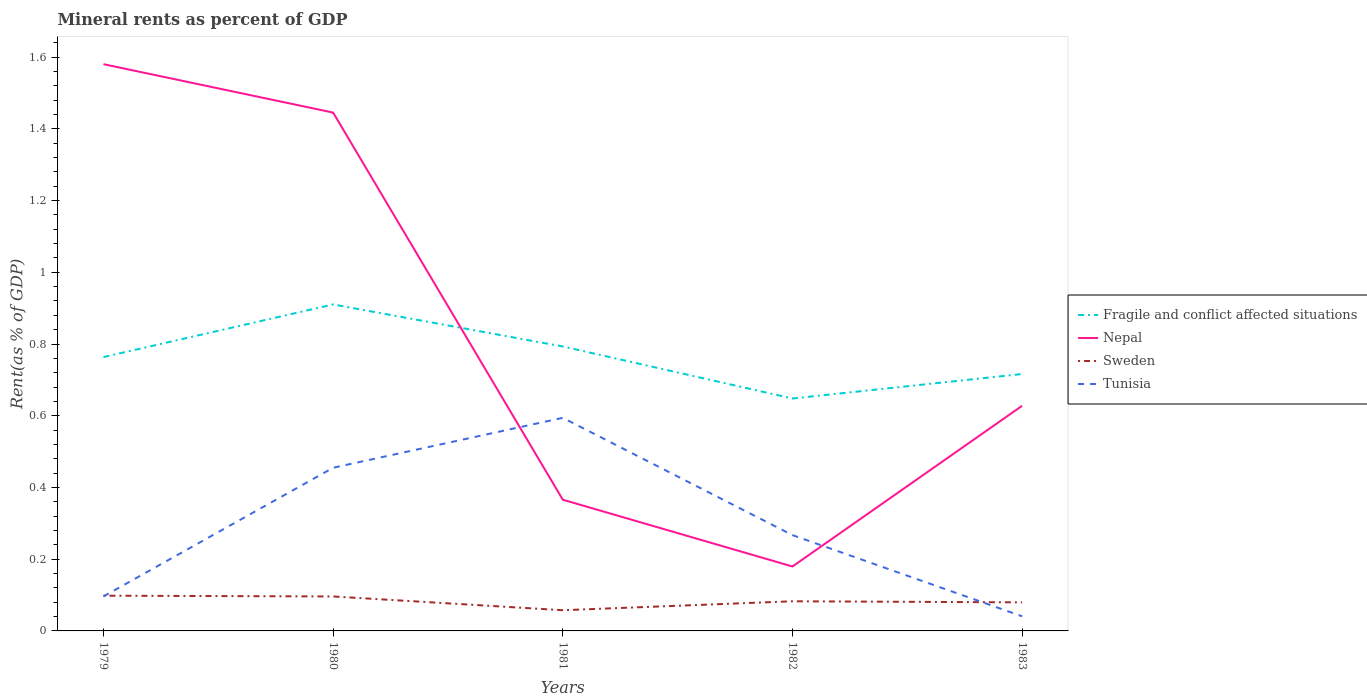How many different coloured lines are there?
Offer a terse response. 4. Is the number of lines equal to the number of legend labels?
Ensure brevity in your answer.  Yes. Across all years, what is the maximum mineral rent in Fragile and conflict affected situations?
Keep it short and to the point. 0.65. What is the total mineral rent in Fragile and conflict affected situations in the graph?
Keep it short and to the point. -0.15. What is the difference between the highest and the second highest mineral rent in Nepal?
Your answer should be compact. 1.4. What is the difference between the highest and the lowest mineral rent in Tunisia?
Provide a short and direct response. 2. How many lines are there?
Offer a terse response. 4. How many years are there in the graph?
Make the answer very short. 5. What is the difference between two consecutive major ticks on the Y-axis?
Your response must be concise. 0.2. Does the graph contain any zero values?
Offer a terse response. No. How many legend labels are there?
Your answer should be very brief. 4. How are the legend labels stacked?
Keep it short and to the point. Vertical. What is the title of the graph?
Your answer should be compact. Mineral rents as percent of GDP. Does "Palau" appear as one of the legend labels in the graph?
Your answer should be very brief. No. What is the label or title of the X-axis?
Offer a terse response. Years. What is the label or title of the Y-axis?
Give a very brief answer. Rent(as % of GDP). What is the Rent(as % of GDP) of Fragile and conflict affected situations in 1979?
Your answer should be very brief. 0.76. What is the Rent(as % of GDP) of Nepal in 1979?
Your answer should be compact. 1.58. What is the Rent(as % of GDP) of Sweden in 1979?
Offer a terse response. 0.1. What is the Rent(as % of GDP) in Tunisia in 1979?
Provide a short and direct response. 0.1. What is the Rent(as % of GDP) of Fragile and conflict affected situations in 1980?
Offer a very short reply. 0.91. What is the Rent(as % of GDP) in Nepal in 1980?
Provide a short and direct response. 1.45. What is the Rent(as % of GDP) of Sweden in 1980?
Your answer should be very brief. 0.1. What is the Rent(as % of GDP) in Tunisia in 1980?
Offer a terse response. 0.46. What is the Rent(as % of GDP) of Fragile and conflict affected situations in 1981?
Offer a terse response. 0.79. What is the Rent(as % of GDP) of Nepal in 1981?
Your response must be concise. 0.37. What is the Rent(as % of GDP) of Sweden in 1981?
Make the answer very short. 0.06. What is the Rent(as % of GDP) in Tunisia in 1981?
Keep it short and to the point. 0.59. What is the Rent(as % of GDP) in Fragile and conflict affected situations in 1982?
Provide a succinct answer. 0.65. What is the Rent(as % of GDP) in Nepal in 1982?
Make the answer very short. 0.18. What is the Rent(as % of GDP) of Sweden in 1982?
Provide a succinct answer. 0.08. What is the Rent(as % of GDP) in Tunisia in 1982?
Your response must be concise. 0.27. What is the Rent(as % of GDP) of Fragile and conflict affected situations in 1983?
Provide a succinct answer. 0.72. What is the Rent(as % of GDP) of Nepal in 1983?
Make the answer very short. 0.63. What is the Rent(as % of GDP) in Sweden in 1983?
Give a very brief answer. 0.08. What is the Rent(as % of GDP) of Tunisia in 1983?
Make the answer very short. 0.04. Across all years, what is the maximum Rent(as % of GDP) of Fragile and conflict affected situations?
Provide a succinct answer. 0.91. Across all years, what is the maximum Rent(as % of GDP) in Nepal?
Your answer should be very brief. 1.58. Across all years, what is the maximum Rent(as % of GDP) of Sweden?
Keep it short and to the point. 0.1. Across all years, what is the maximum Rent(as % of GDP) in Tunisia?
Offer a very short reply. 0.59. Across all years, what is the minimum Rent(as % of GDP) in Fragile and conflict affected situations?
Ensure brevity in your answer.  0.65. Across all years, what is the minimum Rent(as % of GDP) of Nepal?
Give a very brief answer. 0.18. Across all years, what is the minimum Rent(as % of GDP) in Sweden?
Your answer should be very brief. 0.06. Across all years, what is the minimum Rent(as % of GDP) in Tunisia?
Your answer should be very brief. 0.04. What is the total Rent(as % of GDP) in Fragile and conflict affected situations in the graph?
Provide a short and direct response. 3.83. What is the total Rent(as % of GDP) of Nepal in the graph?
Your answer should be very brief. 4.2. What is the total Rent(as % of GDP) of Sweden in the graph?
Provide a short and direct response. 0.41. What is the total Rent(as % of GDP) in Tunisia in the graph?
Keep it short and to the point. 1.45. What is the difference between the Rent(as % of GDP) of Fragile and conflict affected situations in 1979 and that in 1980?
Provide a succinct answer. -0.15. What is the difference between the Rent(as % of GDP) in Nepal in 1979 and that in 1980?
Provide a succinct answer. 0.14. What is the difference between the Rent(as % of GDP) of Sweden in 1979 and that in 1980?
Provide a succinct answer. 0. What is the difference between the Rent(as % of GDP) in Tunisia in 1979 and that in 1980?
Offer a terse response. -0.36. What is the difference between the Rent(as % of GDP) in Fragile and conflict affected situations in 1979 and that in 1981?
Make the answer very short. -0.03. What is the difference between the Rent(as % of GDP) in Nepal in 1979 and that in 1981?
Provide a short and direct response. 1.21. What is the difference between the Rent(as % of GDP) of Sweden in 1979 and that in 1981?
Your answer should be very brief. 0.04. What is the difference between the Rent(as % of GDP) of Tunisia in 1979 and that in 1981?
Give a very brief answer. -0.5. What is the difference between the Rent(as % of GDP) of Fragile and conflict affected situations in 1979 and that in 1982?
Offer a terse response. 0.12. What is the difference between the Rent(as % of GDP) in Nepal in 1979 and that in 1982?
Make the answer very short. 1.4. What is the difference between the Rent(as % of GDP) in Sweden in 1979 and that in 1982?
Provide a succinct answer. 0.02. What is the difference between the Rent(as % of GDP) of Tunisia in 1979 and that in 1982?
Provide a succinct answer. -0.17. What is the difference between the Rent(as % of GDP) in Fragile and conflict affected situations in 1979 and that in 1983?
Provide a short and direct response. 0.05. What is the difference between the Rent(as % of GDP) in Nepal in 1979 and that in 1983?
Provide a succinct answer. 0.95. What is the difference between the Rent(as % of GDP) of Sweden in 1979 and that in 1983?
Ensure brevity in your answer.  0.02. What is the difference between the Rent(as % of GDP) in Tunisia in 1979 and that in 1983?
Provide a succinct answer. 0.06. What is the difference between the Rent(as % of GDP) in Fragile and conflict affected situations in 1980 and that in 1981?
Your answer should be compact. 0.12. What is the difference between the Rent(as % of GDP) in Nepal in 1980 and that in 1981?
Keep it short and to the point. 1.08. What is the difference between the Rent(as % of GDP) in Sweden in 1980 and that in 1981?
Keep it short and to the point. 0.04. What is the difference between the Rent(as % of GDP) in Tunisia in 1980 and that in 1981?
Your answer should be compact. -0.14. What is the difference between the Rent(as % of GDP) in Fragile and conflict affected situations in 1980 and that in 1982?
Make the answer very short. 0.26. What is the difference between the Rent(as % of GDP) in Nepal in 1980 and that in 1982?
Your response must be concise. 1.27. What is the difference between the Rent(as % of GDP) of Sweden in 1980 and that in 1982?
Keep it short and to the point. 0.01. What is the difference between the Rent(as % of GDP) in Tunisia in 1980 and that in 1982?
Your answer should be compact. 0.19. What is the difference between the Rent(as % of GDP) of Fragile and conflict affected situations in 1980 and that in 1983?
Ensure brevity in your answer.  0.19. What is the difference between the Rent(as % of GDP) in Nepal in 1980 and that in 1983?
Provide a succinct answer. 0.82. What is the difference between the Rent(as % of GDP) in Sweden in 1980 and that in 1983?
Offer a terse response. 0.02. What is the difference between the Rent(as % of GDP) in Tunisia in 1980 and that in 1983?
Keep it short and to the point. 0.41. What is the difference between the Rent(as % of GDP) of Fragile and conflict affected situations in 1981 and that in 1982?
Keep it short and to the point. 0.15. What is the difference between the Rent(as % of GDP) in Nepal in 1981 and that in 1982?
Offer a terse response. 0.19. What is the difference between the Rent(as % of GDP) of Sweden in 1981 and that in 1982?
Your answer should be very brief. -0.03. What is the difference between the Rent(as % of GDP) of Tunisia in 1981 and that in 1982?
Keep it short and to the point. 0.33. What is the difference between the Rent(as % of GDP) of Fragile and conflict affected situations in 1981 and that in 1983?
Provide a short and direct response. 0.08. What is the difference between the Rent(as % of GDP) in Nepal in 1981 and that in 1983?
Your answer should be very brief. -0.26. What is the difference between the Rent(as % of GDP) of Sweden in 1981 and that in 1983?
Keep it short and to the point. -0.02. What is the difference between the Rent(as % of GDP) of Tunisia in 1981 and that in 1983?
Provide a short and direct response. 0.55. What is the difference between the Rent(as % of GDP) of Fragile and conflict affected situations in 1982 and that in 1983?
Give a very brief answer. -0.07. What is the difference between the Rent(as % of GDP) in Nepal in 1982 and that in 1983?
Ensure brevity in your answer.  -0.45. What is the difference between the Rent(as % of GDP) of Sweden in 1982 and that in 1983?
Provide a short and direct response. 0. What is the difference between the Rent(as % of GDP) of Tunisia in 1982 and that in 1983?
Offer a very short reply. 0.23. What is the difference between the Rent(as % of GDP) in Fragile and conflict affected situations in 1979 and the Rent(as % of GDP) in Nepal in 1980?
Your response must be concise. -0.68. What is the difference between the Rent(as % of GDP) of Fragile and conflict affected situations in 1979 and the Rent(as % of GDP) of Sweden in 1980?
Keep it short and to the point. 0.67. What is the difference between the Rent(as % of GDP) of Fragile and conflict affected situations in 1979 and the Rent(as % of GDP) of Tunisia in 1980?
Give a very brief answer. 0.31. What is the difference between the Rent(as % of GDP) of Nepal in 1979 and the Rent(as % of GDP) of Sweden in 1980?
Keep it short and to the point. 1.48. What is the difference between the Rent(as % of GDP) of Nepal in 1979 and the Rent(as % of GDP) of Tunisia in 1980?
Keep it short and to the point. 1.13. What is the difference between the Rent(as % of GDP) in Sweden in 1979 and the Rent(as % of GDP) in Tunisia in 1980?
Provide a succinct answer. -0.36. What is the difference between the Rent(as % of GDP) in Fragile and conflict affected situations in 1979 and the Rent(as % of GDP) in Nepal in 1981?
Your answer should be compact. 0.4. What is the difference between the Rent(as % of GDP) of Fragile and conflict affected situations in 1979 and the Rent(as % of GDP) of Sweden in 1981?
Give a very brief answer. 0.71. What is the difference between the Rent(as % of GDP) in Fragile and conflict affected situations in 1979 and the Rent(as % of GDP) in Tunisia in 1981?
Make the answer very short. 0.17. What is the difference between the Rent(as % of GDP) of Nepal in 1979 and the Rent(as % of GDP) of Sweden in 1981?
Keep it short and to the point. 1.52. What is the difference between the Rent(as % of GDP) of Nepal in 1979 and the Rent(as % of GDP) of Tunisia in 1981?
Offer a terse response. 0.99. What is the difference between the Rent(as % of GDP) of Sweden in 1979 and the Rent(as % of GDP) of Tunisia in 1981?
Provide a succinct answer. -0.5. What is the difference between the Rent(as % of GDP) in Fragile and conflict affected situations in 1979 and the Rent(as % of GDP) in Nepal in 1982?
Keep it short and to the point. 0.58. What is the difference between the Rent(as % of GDP) of Fragile and conflict affected situations in 1979 and the Rent(as % of GDP) of Sweden in 1982?
Your response must be concise. 0.68. What is the difference between the Rent(as % of GDP) in Fragile and conflict affected situations in 1979 and the Rent(as % of GDP) in Tunisia in 1982?
Ensure brevity in your answer.  0.5. What is the difference between the Rent(as % of GDP) in Nepal in 1979 and the Rent(as % of GDP) in Sweden in 1982?
Make the answer very short. 1.5. What is the difference between the Rent(as % of GDP) of Nepal in 1979 and the Rent(as % of GDP) of Tunisia in 1982?
Ensure brevity in your answer.  1.31. What is the difference between the Rent(as % of GDP) in Sweden in 1979 and the Rent(as % of GDP) in Tunisia in 1982?
Give a very brief answer. -0.17. What is the difference between the Rent(as % of GDP) in Fragile and conflict affected situations in 1979 and the Rent(as % of GDP) in Nepal in 1983?
Your answer should be compact. 0.14. What is the difference between the Rent(as % of GDP) of Fragile and conflict affected situations in 1979 and the Rent(as % of GDP) of Sweden in 1983?
Ensure brevity in your answer.  0.68. What is the difference between the Rent(as % of GDP) of Fragile and conflict affected situations in 1979 and the Rent(as % of GDP) of Tunisia in 1983?
Your response must be concise. 0.72. What is the difference between the Rent(as % of GDP) of Nepal in 1979 and the Rent(as % of GDP) of Sweden in 1983?
Keep it short and to the point. 1.5. What is the difference between the Rent(as % of GDP) in Nepal in 1979 and the Rent(as % of GDP) in Tunisia in 1983?
Offer a terse response. 1.54. What is the difference between the Rent(as % of GDP) of Sweden in 1979 and the Rent(as % of GDP) of Tunisia in 1983?
Keep it short and to the point. 0.06. What is the difference between the Rent(as % of GDP) of Fragile and conflict affected situations in 1980 and the Rent(as % of GDP) of Nepal in 1981?
Make the answer very short. 0.54. What is the difference between the Rent(as % of GDP) of Fragile and conflict affected situations in 1980 and the Rent(as % of GDP) of Sweden in 1981?
Give a very brief answer. 0.85. What is the difference between the Rent(as % of GDP) in Fragile and conflict affected situations in 1980 and the Rent(as % of GDP) in Tunisia in 1981?
Your answer should be very brief. 0.32. What is the difference between the Rent(as % of GDP) of Nepal in 1980 and the Rent(as % of GDP) of Sweden in 1981?
Offer a very short reply. 1.39. What is the difference between the Rent(as % of GDP) of Nepal in 1980 and the Rent(as % of GDP) of Tunisia in 1981?
Provide a succinct answer. 0.85. What is the difference between the Rent(as % of GDP) in Sweden in 1980 and the Rent(as % of GDP) in Tunisia in 1981?
Ensure brevity in your answer.  -0.5. What is the difference between the Rent(as % of GDP) of Fragile and conflict affected situations in 1980 and the Rent(as % of GDP) of Nepal in 1982?
Provide a short and direct response. 0.73. What is the difference between the Rent(as % of GDP) in Fragile and conflict affected situations in 1980 and the Rent(as % of GDP) in Sweden in 1982?
Your response must be concise. 0.83. What is the difference between the Rent(as % of GDP) in Fragile and conflict affected situations in 1980 and the Rent(as % of GDP) in Tunisia in 1982?
Your answer should be very brief. 0.64. What is the difference between the Rent(as % of GDP) in Nepal in 1980 and the Rent(as % of GDP) in Sweden in 1982?
Provide a short and direct response. 1.36. What is the difference between the Rent(as % of GDP) of Nepal in 1980 and the Rent(as % of GDP) of Tunisia in 1982?
Offer a terse response. 1.18. What is the difference between the Rent(as % of GDP) in Sweden in 1980 and the Rent(as % of GDP) in Tunisia in 1982?
Offer a terse response. -0.17. What is the difference between the Rent(as % of GDP) of Fragile and conflict affected situations in 1980 and the Rent(as % of GDP) of Nepal in 1983?
Your answer should be very brief. 0.28. What is the difference between the Rent(as % of GDP) of Fragile and conflict affected situations in 1980 and the Rent(as % of GDP) of Sweden in 1983?
Provide a short and direct response. 0.83. What is the difference between the Rent(as % of GDP) of Fragile and conflict affected situations in 1980 and the Rent(as % of GDP) of Tunisia in 1983?
Give a very brief answer. 0.87. What is the difference between the Rent(as % of GDP) in Nepal in 1980 and the Rent(as % of GDP) in Sweden in 1983?
Make the answer very short. 1.37. What is the difference between the Rent(as % of GDP) in Nepal in 1980 and the Rent(as % of GDP) in Tunisia in 1983?
Your response must be concise. 1.4. What is the difference between the Rent(as % of GDP) of Sweden in 1980 and the Rent(as % of GDP) of Tunisia in 1983?
Provide a succinct answer. 0.06. What is the difference between the Rent(as % of GDP) in Fragile and conflict affected situations in 1981 and the Rent(as % of GDP) in Nepal in 1982?
Your answer should be very brief. 0.61. What is the difference between the Rent(as % of GDP) in Fragile and conflict affected situations in 1981 and the Rent(as % of GDP) in Sweden in 1982?
Provide a short and direct response. 0.71. What is the difference between the Rent(as % of GDP) of Fragile and conflict affected situations in 1981 and the Rent(as % of GDP) of Tunisia in 1982?
Provide a short and direct response. 0.53. What is the difference between the Rent(as % of GDP) in Nepal in 1981 and the Rent(as % of GDP) in Sweden in 1982?
Your answer should be very brief. 0.28. What is the difference between the Rent(as % of GDP) in Nepal in 1981 and the Rent(as % of GDP) in Tunisia in 1982?
Make the answer very short. 0.1. What is the difference between the Rent(as % of GDP) of Sweden in 1981 and the Rent(as % of GDP) of Tunisia in 1982?
Your answer should be compact. -0.21. What is the difference between the Rent(as % of GDP) in Fragile and conflict affected situations in 1981 and the Rent(as % of GDP) in Nepal in 1983?
Ensure brevity in your answer.  0.17. What is the difference between the Rent(as % of GDP) in Fragile and conflict affected situations in 1981 and the Rent(as % of GDP) in Sweden in 1983?
Ensure brevity in your answer.  0.71. What is the difference between the Rent(as % of GDP) in Fragile and conflict affected situations in 1981 and the Rent(as % of GDP) in Tunisia in 1983?
Keep it short and to the point. 0.75. What is the difference between the Rent(as % of GDP) in Nepal in 1981 and the Rent(as % of GDP) in Sweden in 1983?
Your answer should be very brief. 0.29. What is the difference between the Rent(as % of GDP) in Nepal in 1981 and the Rent(as % of GDP) in Tunisia in 1983?
Give a very brief answer. 0.33. What is the difference between the Rent(as % of GDP) in Sweden in 1981 and the Rent(as % of GDP) in Tunisia in 1983?
Provide a short and direct response. 0.02. What is the difference between the Rent(as % of GDP) of Fragile and conflict affected situations in 1982 and the Rent(as % of GDP) of Nepal in 1983?
Keep it short and to the point. 0.02. What is the difference between the Rent(as % of GDP) in Fragile and conflict affected situations in 1982 and the Rent(as % of GDP) in Sweden in 1983?
Give a very brief answer. 0.57. What is the difference between the Rent(as % of GDP) of Fragile and conflict affected situations in 1982 and the Rent(as % of GDP) of Tunisia in 1983?
Provide a short and direct response. 0.61. What is the difference between the Rent(as % of GDP) of Nepal in 1982 and the Rent(as % of GDP) of Tunisia in 1983?
Keep it short and to the point. 0.14. What is the difference between the Rent(as % of GDP) in Sweden in 1982 and the Rent(as % of GDP) in Tunisia in 1983?
Your response must be concise. 0.04. What is the average Rent(as % of GDP) of Fragile and conflict affected situations per year?
Offer a terse response. 0.77. What is the average Rent(as % of GDP) in Nepal per year?
Your answer should be compact. 0.84. What is the average Rent(as % of GDP) in Sweden per year?
Provide a succinct answer. 0.08. What is the average Rent(as % of GDP) in Tunisia per year?
Your response must be concise. 0.29. In the year 1979, what is the difference between the Rent(as % of GDP) in Fragile and conflict affected situations and Rent(as % of GDP) in Nepal?
Offer a very short reply. -0.82. In the year 1979, what is the difference between the Rent(as % of GDP) of Fragile and conflict affected situations and Rent(as % of GDP) of Sweden?
Provide a short and direct response. 0.67. In the year 1979, what is the difference between the Rent(as % of GDP) in Fragile and conflict affected situations and Rent(as % of GDP) in Tunisia?
Offer a terse response. 0.67. In the year 1979, what is the difference between the Rent(as % of GDP) in Nepal and Rent(as % of GDP) in Sweden?
Provide a short and direct response. 1.48. In the year 1979, what is the difference between the Rent(as % of GDP) in Nepal and Rent(as % of GDP) in Tunisia?
Provide a short and direct response. 1.48. In the year 1979, what is the difference between the Rent(as % of GDP) of Sweden and Rent(as % of GDP) of Tunisia?
Give a very brief answer. 0. In the year 1980, what is the difference between the Rent(as % of GDP) of Fragile and conflict affected situations and Rent(as % of GDP) of Nepal?
Make the answer very short. -0.54. In the year 1980, what is the difference between the Rent(as % of GDP) of Fragile and conflict affected situations and Rent(as % of GDP) of Sweden?
Make the answer very short. 0.81. In the year 1980, what is the difference between the Rent(as % of GDP) of Fragile and conflict affected situations and Rent(as % of GDP) of Tunisia?
Provide a succinct answer. 0.46. In the year 1980, what is the difference between the Rent(as % of GDP) of Nepal and Rent(as % of GDP) of Sweden?
Keep it short and to the point. 1.35. In the year 1980, what is the difference between the Rent(as % of GDP) of Nepal and Rent(as % of GDP) of Tunisia?
Ensure brevity in your answer.  0.99. In the year 1980, what is the difference between the Rent(as % of GDP) in Sweden and Rent(as % of GDP) in Tunisia?
Offer a terse response. -0.36. In the year 1981, what is the difference between the Rent(as % of GDP) of Fragile and conflict affected situations and Rent(as % of GDP) of Nepal?
Your response must be concise. 0.43. In the year 1981, what is the difference between the Rent(as % of GDP) of Fragile and conflict affected situations and Rent(as % of GDP) of Sweden?
Offer a very short reply. 0.74. In the year 1981, what is the difference between the Rent(as % of GDP) of Fragile and conflict affected situations and Rent(as % of GDP) of Tunisia?
Provide a succinct answer. 0.2. In the year 1981, what is the difference between the Rent(as % of GDP) of Nepal and Rent(as % of GDP) of Sweden?
Offer a terse response. 0.31. In the year 1981, what is the difference between the Rent(as % of GDP) of Nepal and Rent(as % of GDP) of Tunisia?
Offer a terse response. -0.23. In the year 1981, what is the difference between the Rent(as % of GDP) of Sweden and Rent(as % of GDP) of Tunisia?
Provide a succinct answer. -0.54. In the year 1982, what is the difference between the Rent(as % of GDP) in Fragile and conflict affected situations and Rent(as % of GDP) in Nepal?
Your answer should be compact. 0.47. In the year 1982, what is the difference between the Rent(as % of GDP) in Fragile and conflict affected situations and Rent(as % of GDP) in Sweden?
Provide a short and direct response. 0.57. In the year 1982, what is the difference between the Rent(as % of GDP) of Fragile and conflict affected situations and Rent(as % of GDP) of Tunisia?
Keep it short and to the point. 0.38. In the year 1982, what is the difference between the Rent(as % of GDP) of Nepal and Rent(as % of GDP) of Sweden?
Your answer should be compact. 0.1. In the year 1982, what is the difference between the Rent(as % of GDP) of Nepal and Rent(as % of GDP) of Tunisia?
Offer a terse response. -0.09. In the year 1982, what is the difference between the Rent(as % of GDP) of Sweden and Rent(as % of GDP) of Tunisia?
Make the answer very short. -0.18. In the year 1983, what is the difference between the Rent(as % of GDP) of Fragile and conflict affected situations and Rent(as % of GDP) of Nepal?
Provide a succinct answer. 0.09. In the year 1983, what is the difference between the Rent(as % of GDP) of Fragile and conflict affected situations and Rent(as % of GDP) of Sweden?
Ensure brevity in your answer.  0.64. In the year 1983, what is the difference between the Rent(as % of GDP) of Fragile and conflict affected situations and Rent(as % of GDP) of Tunisia?
Provide a succinct answer. 0.68. In the year 1983, what is the difference between the Rent(as % of GDP) of Nepal and Rent(as % of GDP) of Sweden?
Offer a very short reply. 0.55. In the year 1983, what is the difference between the Rent(as % of GDP) in Nepal and Rent(as % of GDP) in Tunisia?
Your response must be concise. 0.59. In the year 1983, what is the difference between the Rent(as % of GDP) in Sweden and Rent(as % of GDP) in Tunisia?
Ensure brevity in your answer.  0.04. What is the ratio of the Rent(as % of GDP) in Fragile and conflict affected situations in 1979 to that in 1980?
Provide a short and direct response. 0.84. What is the ratio of the Rent(as % of GDP) in Nepal in 1979 to that in 1980?
Give a very brief answer. 1.09. What is the ratio of the Rent(as % of GDP) of Sweden in 1979 to that in 1980?
Ensure brevity in your answer.  1.02. What is the ratio of the Rent(as % of GDP) of Tunisia in 1979 to that in 1980?
Provide a short and direct response. 0.21. What is the ratio of the Rent(as % of GDP) of Fragile and conflict affected situations in 1979 to that in 1981?
Keep it short and to the point. 0.96. What is the ratio of the Rent(as % of GDP) in Nepal in 1979 to that in 1981?
Your response must be concise. 4.32. What is the ratio of the Rent(as % of GDP) of Sweden in 1979 to that in 1981?
Provide a short and direct response. 1.7. What is the ratio of the Rent(as % of GDP) in Tunisia in 1979 to that in 1981?
Your answer should be very brief. 0.16. What is the ratio of the Rent(as % of GDP) of Fragile and conflict affected situations in 1979 to that in 1982?
Provide a short and direct response. 1.18. What is the ratio of the Rent(as % of GDP) in Nepal in 1979 to that in 1982?
Your answer should be very brief. 8.8. What is the ratio of the Rent(as % of GDP) in Sweden in 1979 to that in 1982?
Provide a succinct answer. 1.19. What is the ratio of the Rent(as % of GDP) of Tunisia in 1979 to that in 1982?
Keep it short and to the point. 0.36. What is the ratio of the Rent(as % of GDP) of Fragile and conflict affected situations in 1979 to that in 1983?
Provide a succinct answer. 1.07. What is the ratio of the Rent(as % of GDP) in Nepal in 1979 to that in 1983?
Offer a very short reply. 2.52. What is the ratio of the Rent(as % of GDP) in Sweden in 1979 to that in 1983?
Your response must be concise. 1.23. What is the ratio of the Rent(as % of GDP) of Tunisia in 1979 to that in 1983?
Offer a very short reply. 2.36. What is the ratio of the Rent(as % of GDP) in Fragile and conflict affected situations in 1980 to that in 1981?
Your answer should be very brief. 1.15. What is the ratio of the Rent(as % of GDP) in Nepal in 1980 to that in 1981?
Your response must be concise. 3.95. What is the ratio of the Rent(as % of GDP) of Sweden in 1980 to that in 1981?
Your response must be concise. 1.67. What is the ratio of the Rent(as % of GDP) of Tunisia in 1980 to that in 1981?
Provide a succinct answer. 0.77. What is the ratio of the Rent(as % of GDP) in Fragile and conflict affected situations in 1980 to that in 1982?
Offer a very short reply. 1.4. What is the ratio of the Rent(as % of GDP) in Nepal in 1980 to that in 1982?
Offer a terse response. 8.04. What is the ratio of the Rent(as % of GDP) in Sweden in 1980 to that in 1982?
Give a very brief answer. 1.16. What is the ratio of the Rent(as % of GDP) of Tunisia in 1980 to that in 1982?
Offer a terse response. 1.7. What is the ratio of the Rent(as % of GDP) of Fragile and conflict affected situations in 1980 to that in 1983?
Offer a terse response. 1.27. What is the ratio of the Rent(as % of GDP) in Nepal in 1980 to that in 1983?
Provide a succinct answer. 2.3. What is the ratio of the Rent(as % of GDP) of Sweden in 1980 to that in 1983?
Your answer should be compact. 1.21. What is the ratio of the Rent(as % of GDP) in Tunisia in 1980 to that in 1983?
Provide a succinct answer. 11.15. What is the ratio of the Rent(as % of GDP) of Fragile and conflict affected situations in 1981 to that in 1982?
Provide a short and direct response. 1.22. What is the ratio of the Rent(as % of GDP) of Nepal in 1981 to that in 1982?
Ensure brevity in your answer.  2.04. What is the ratio of the Rent(as % of GDP) in Sweden in 1981 to that in 1982?
Make the answer very short. 0.7. What is the ratio of the Rent(as % of GDP) of Tunisia in 1981 to that in 1982?
Offer a very short reply. 2.22. What is the ratio of the Rent(as % of GDP) in Fragile and conflict affected situations in 1981 to that in 1983?
Provide a short and direct response. 1.11. What is the ratio of the Rent(as % of GDP) in Nepal in 1981 to that in 1983?
Offer a terse response. 0.58. What is the ratio of the Rent(as % of GDP) of Sweden in 1981 to that in 1983?
Your response must be concise. 0.72. What is the ratio of the Rent(as % of GDP) in Tunisia in 1981 to that in 1983?
Your answer should be very brief. 14.56. What is the ratio of the Rent(as % of GDP) in Fragile and conflict affected situations in 1982 to that in 1983?
Keep it short and to the point. 0.9. What is the ratio of the Rent(as % of GDP) in Nepal in 1982 to that in 1983?
Provide a succinct answer. 0.29. What is the ratio of the Rent(as % of GDP) of Sweden in 1982 to that in 1983?
Give a very brief answer. 1.04. What is the ratio of the Rent(as % of GDP) in Tunisia in 1982 to that in 1983?
Provide a short and direct response. 6.55. What is the difference between the highest and the second highest Rent(as % of GDP) in Fragile and conflict affected situations?
Make the answer very short. 0.12. What is the difference between the highest and the second highest Rent(as % of GDP) of Nepal?
Give a very brief answer. 0.14. What is the difference between the highest and the second highest Rent(as % of GDP) of Sweden?
Provide a succinct answer. 0. What is the difference between the highest and the second highest Rent(as % of GDP) of Tunisia?
Provide a short and direct response. 0.14. What is the difference between the highest and the lowest Rent(as % of GDP) of Fragile and conflict affected situations?
Offer a very short reply. 0.26. What is the difference between the highest and the lowest Rent(as % of GDP) of Nepal?
Offer a terse response. 1.4. What is the difference between the highest and the lowest Rent(as % of GDP) in Sweden?
Your answer should be very brief. 0.04. What is the difference between the highest and the lowest Rent(as % of GDP) in Tunisia?
Give a very brief answer. 0.55. 